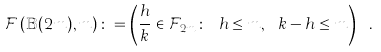<formula> <loc_0><loc_0><loc_500><loc_500>\mathcal { F } \left ( \mathbb { B } ( 2 m ) , m \right ) \colon = \left ( \frac { h } { k } \in \mathcal { F } _ { 2 m } \colon \ h \leq m , \ k - h \leq m \right ) \ .</formula> 